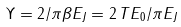<formula> <loc_0><loc_0><loc_500><loc_500>\Upsilon = 2 / \pi \beta E _ { J } = 2 \, T E _ { 0 } / \pi E _ { J }</formula> 